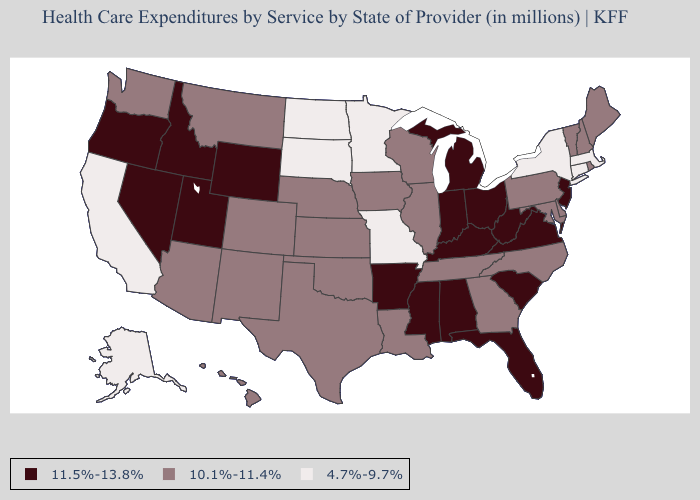What is the value of Iowa?
Concise answer only. 10.1%-11.4%. Among the states that border Indiana , which have the lowest value?
Write a very short answer. Illinois. Among the states that border New Hampshire , which have the highest value?
Be succinct. Maine, Vermont. Name the states that have a value in the range 10.1%-11.4%?
Write a very short answer. Arizona, Colorado, Delaware, Georgia, Hawaii, Illinois, Iowa, Kansas, Louisiana, Maine, Maryland, Montana, Nebraska, New Hampshire, New Mexico, North Carolina, Oklahoma, Pennsylvania, Rhode Island, Tennessee, Texas, Vermont, Washington, Wisconsin. What is the value of Maine?
Keep it brief. 10.1%-11.4%. What is the value of Hawaii?
Short answer required. 10.1%-11.4%. What is the lowest value in states that border Kentucky?
Write a very short answer. 4.7%-9.7%. Name the states that have a value in the range 10.1%-11.4%?
Keep it brief. Arizona, Colorado, Delaware, Georgia, Hawaii, Illinois, Iowa, Kansas, Louisiana, Maine, Maryland, Montana, Nebraska, New Hampshire, New Mexico, North Carolina, Oklahoma, Pennsylvania, Rhode Island, Tennessee, Texas, Vermont, Washington, Wisconsin. Name the states that have a value in the range 4.7%-9.7%?
Keep it brief. Alaska, California, Connecticut, Massachusetts, Minnesota, Missouri, New York, North Dakota, South Dakota. Which states have the highest value in the USA?
Answer briefly. Alabama, Arkansas, Florida, Idaho, Indiana, Kentucky, Michigan, Mississippi, Nevada, New Jersey, Ohio, Oregon, South Carolina, Utah, Virginia, West Virginia, Wyoming. Which states have the lowest value in the West?
Give a very brief answer. Alaska, California. What is the lowest value in the MidWest?
Short answer required. 4.7%-9.7%. How many symbols are there in the legend?
Quick response, please. 3. Name the states that have a value in the range 10.1%-11.4%?
Concise answer only. Arizona, Colorado, Delaware, Georgia, Hawaii, Illinois, Iowa, Kansas, Louisiana, Maine, Maryland, Montana, Nebraska, New Hampshire, New Mexico, North Carolina, Oklahoma, Pennsylvania, Rhode Island, Tennessee, Texas, Vermont, Washington, Wisconsin. 